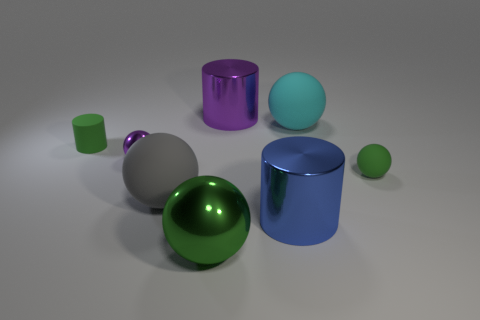What material is the purple thing that is the same shape as the cyan object?
Give a very brief answer. Metal. There is a tiny rubber thing right of the tiny green cylinder; what is its color?
Your answer should be compact. Green. How big is the gray sphere?
Give a very brief answer. Large. There is a purple cylinder; does it have the same size as the ball behind the green cylinder?
Your response must be concise. Yes. There is a small sphere on the right side of the big rubber object that is in front of the tiny thing to the right of the large cyan rubber sphere; what is its color?
Your answer should be very brief. Green. Do the green ball that is on the right side of the cyan sphere and the gray thing have the same material?
Your answer should be compact. Yes. What is the material of the gray sphere that is the same size as the blue thing?
Provide a succinct answer. Rubber. There is a large rubber object that is on the right side of the gray matte object; is its shape the same as the small green object on the right side of the cyan sphere?
Provide a short and direct response. Yes. There is a gray thing that is the same size as the blue shiny cylinder; what shape is it?
Your answer should be very brief. Sphere. Does the small ball that is left of the big purple cylinder have the same material as the small green object on the left side of the large metallic ball?
Your answer should be very brief. No. 